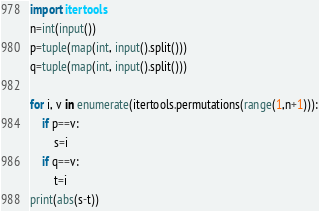Convert code to text. <code><loc_0><loc_0><loc_500><loc_500><_Python_>import itertools
n=int(input())
p=tuple(map(int, input().split()))
q=tuple(map(int, input().split()))

for i, v in enumerate(itertools.permutations(range(1,n+1))):
    if p==v:
        s=i
    if q==v:
        t=i
print(abs(s-t))</code> 